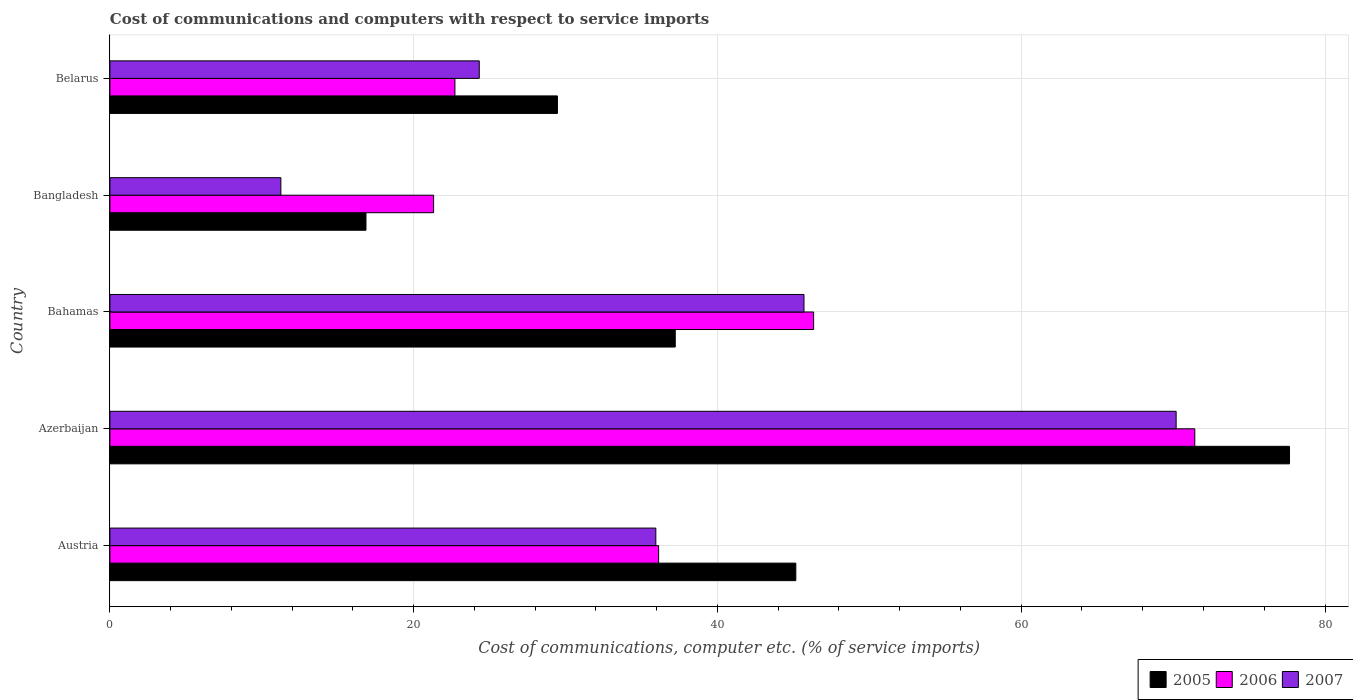How many different coloured bars are there?
Your answer should be very brief. 3. Are the number of bars on each tick of the Y-axis equal?
Your answer should be compact. Yes. How many bars are there on the 3rd tick from the top?
Provide a short and direct response. 3. What is the label of the 2nd group of bars from the top?
Your answer should be compact. Bangladesh. In how many cases, is the number of bars for a given country not equal to the number of legend labels?
Make the answer very short. 0. What is the cost of communications and computers in 2007 in Austria?
Provide a succinct answer. 35.94. Across all countries, what is the maximum cost of communications and computers in 2007?
Provide a succinct answer. 70.2. Across all countries, what is the minimum cost of communications and computers in 2006?
Offer a very short reply. 21.31. In which country was the cost of communications and computers in 2007 maximum?
Offer a very short reply. Azerbaijan. In which country was the cost of communications and computers in 2006 minimum?
Your answer should be very brief. Bangladesh. What is the total cost of communications and computers in 2007 in the graph?
Make the answer very short. 187.42. What is the difference between the cost of communications and computers in 2006 in Bahamas and that in Bangladesh?
Make the answer very short. 25.02. What is the difference between the cost of communications and computers in 2007 in Azerbaijan and the cost of communications and computers in 2005 in Austria?
Ensure brevity in your answer.  25.04. What is the average cost of communications and computers in 2005 per country?
Your answer should be compact. 41.27. What is the difference between the cost of communications and computers in 2006 and cost of communications and computers in 2005 in Belarus?
Provide a succinct answer. -6.75. What is the ratio of the cost of communications and computers in 2005 in Bangladesh to that in Belarus?
Provide a short and direct response. 0.57. Is the cost of communications and computers in 2005 in Azerbaijan less than that in Bahamas?
Ensure brevity in your answer.  No. What is the difference between the highest and the second highest cost of communications and computers in 2005?
Keep it short and to the point. 32.5. What is the difference between the highest and the lowest cost of communications and computers in 2005?
Offer a very short reply. 60.8. Is the sum of the cost of communications and computers in 2007 in Austria and Belarus greater than the maximum cost of communications and computers in 2005 across all countries?
Ensure brevity in your answer.  No. What does the 2nd bar from the top in Belarus represents?
Provide a succinct answer. 2006. How many countries are there in the graph?
Offer a terse response. 5. What is the difference between two consecutive major ticks on the X-axis?
Make the answer very short. 20. Does the graph contain any zero values?
Your answer should be compact. No. Where does the legend appear in the graph?
Your response must be concise. Bottom right. How many legend labels are there?
Your response must be concise. 3. What is the title of the graph?
Offer a terse response. Cost of communications and computers with respect to service imports. What is the label or title of the X-axis?
Provide a succinct answer. Cost of communications, computer etc. (% of service imports). What is the label or title of the Y-axis?
Make the answer very short. Country. What is the Cost of communications, computer etc. (% of service imports) in 2005 in Austria?
Your answer should be very brief. 45.16. What is the Cost of communications, computer etc. (% of service imports) in 2006 in Austria?
Provide a succinct answer. 36.13. What is the Cost of communications, computer etc. (% of service imports) in 2007 in Austria?
Provide a succinct answer. 35.94. What is the Cost of communications, computer etc. (% of service imports) of 2005 in Azerbaijan?
Provide a succinct answer. 77.66. What is the Cost of communications, computer etc. (% of service imports) in 2006 in Azerbaijan?
Make the answer very short. 71.43. What is the Cost of communications, computer etc. (% of service imports) in 2007 in Azerbaijan?
Your answer should be very brief. 70.2. What is the Cost of communications, computer etc. (% of service imports) of 2005 in Bahamas?
Your response must be concise. 37.22. What is the Cost of communications, computer etc. (% of service imports) in 2006 in Bahamas?
Your response must be concise. 46.33. What is the Cost of communications, computer etc. (% of service imports) of 2007 in Bahamas?
Provide a short and direct response. 45.7. What is the Cost of communications, computer etc. (% of service imports) of 2005 in Bangladesh?
Provide a short and direct response. 16.86. What is the Cost of communications, computer etc. (% of service imports) of 2006 in Bangladesh?
Ensure brevity in your answer.  21.31. What is the Cost of communications, computer etc. (% of service imports) of 2007 in Bangladesh?
Your answer should be compact. 11.26. What is the Cost of communications, computer etc. (% of service imports) in 2005 in Belarus?
Your answer should be very brief. 29.47. What is the Cost of communications, computer etc. (% of service imports) of 2006 in Belarus?
Make the answer very short. 22.72. What is the Cost of communications, computer etc. (% of service imports) in 2007 in Belarus?
Your answer should be very brief. 24.32. Across all countries, what is the maximum Cost of communications, computer etc. (% of service imports) of 2005?
Keep it short and to the point. 77.66. Across all countries, what is the maximum Cost of communications, computer etc. (% of service imports) of 2006?
Give a very brief answer. 71.43. Across all countries, what is the maximum Cost of communications, computer etc. (% of service imports) of 2007?
Make the answer very short. 70.2. Across all countries, what is the minimum Cost of communications, computer etc. (% of service imports) in 2005?
Provide a succinct answer. 16.86. Across all countries, what is the minimum Cost of communications, computer etc. (% of service imports) of 2006?
Provide a succinct answer. 21.31. Across all countries, what is the minimum Cost of communications, computer etc. (% of service imports) of 2007?
Keep it short and to the point. 11.26. What is the total Cost of communications, computer etc. (% of service imports) of 2005 in the graph?
Keep it short and to the point. 206.37. What is the total Cost of communications, computer etc. (% of service imports) of 2006 in the graph?
Ensure brevity in your answer.  197.92. What is the total Cost of communications, computer etc. (% of service imports) in 2007 in the graph?
Your response must be concise. 187.42. What is the difference between the Cost of communications, computer etc. (% of service imports) in 2005 in Austria and that in Azerbaijan?
Offer a terse response. -32.5. What is the difference between the Cost of communications, computer etc. (% of service imports) in 2006 in Austria and that in Azerbaijan?
Make the answer very short. -35.3. What is the difference between the Cost of communications, computer etc. (% of service imports) of 2007 in Austria and that in Azerbaijan?
Offer a very short reply. -34.26. What is the difference between the Cost of communications, computer etc. (% of service imports) in 2005 in Austria and that in Bahamas?
Ensure brevity in your answer.  7.94. What is the difference between the Cost of communications, computer etc. (% of service imports) in 2006 in Austria and that in Bahamas?
Provide a short and direct response. -10.2. What is the difference between the Cost of communications, computer etc. (% of service imports) in 2007 in Austria and that in Bahamas?
Make the answer very short. -9.75. What is the difference between the Cost of communications, computer etc. (% of service imports) of 2005 in Austria and that in Bangladesh?
Offer a very short reply. 28.3. What is the difference between the Cost of communications, computer etc. (% of service imports) of 2006 in Austria and that in Bangladesh?
Offer a terse response. 14.81. What is the difference between the Cost of communications, computer etc. (% of service imports) of 2007 in Austria and that in Bangladesh?
Your answer should be compact. 24.69. What is the difference between the Cost of communications, computer etc. (% of service imports) in 2005 in Austria and that in Belarus?
Make the answer very short. 15.7. What is the difference between the Cost of communications, computer etc. (% of service imports) of 2006 in Austria and that in Belarus?
Keep it short and to the point. 13.41. What is the difference between the Cost of communications, computer etc. (% of service imports) of 2007 in Austria and that in Belarus?
Your answer should be very brief. 11.62. What is the difference between the Cost of communications, computer etc. (% of service imports) of 2005 in Azerbaijan and that in Bahamas?
Provide a succinct answer. 40.44. What is the difference between the Cost of communications, computer etc. (% of service imports) of 2006 in Azerbaijan and that in Bahamas?
Your response must be concise. 25.1. What is the difference between the Cost of communications, computer etc. (% of service imports) of 2007 in Azerbaijan and that in Bahamas?
Give a very brief answer. 24.5. What is the difference between the Cost of communications, computer etc. (% of service imports) of 2005 in Azerbaijan and that in Bangladesh?
Provide a short and direct response. 60.8. What is the difference between the Cost of communications, computer etc. (% of service imports) of 2006 in Azerbaijan and that in Bangladesh?
Your answer should be very brief. 50.12. What is the difference between the Cost of communications, computer etc. (% of service imports) in 2007 in Azerbaijan and that in Bangladesh?
Provide a succinct answer. 58.94. What is the difference between the Cost of communications, computer etc. (% of service imports) in 2005 in Azerbaijan and that in Belarus?
Your response must be concise. 48.2. What is the difference between the Cost of communications, computer etc. (% of service imports) in 2006 in Azerbaijan and that in Belarus?
Make the answer very short. 48.71. What is the difference between the Cost of communications, computer etc. (% of service imports) in 2007 in Azerbaijan and that in Belarus?
Make the answer very short. 45.88. What is the difference between the Cost of communications, computer etc. (% of service imports) in 2005 in Bahamas and that in Bangladesh?
Your response must be concise. 20.36. What is the difference between the Cost of communications, computer etc. (% of service imports) in 2006 in Bahamas and that in Bangladesh?
Your answer should be very brief. 25.02. What is the difference between the Cost of communications, computer etc. (% of service imports) of 2007 in Bahamas and that in Bangladesh?
Your answer should be compact. 34.44. What is the difference between the Cost of communications, computer etc. (% of service imports) of 2005 in Bahamas and that in Belarus?
Provide a short and direct response. 7.76. What is the difference between the Cost of communications, computer etc. (% of service imports) of 2006 in Bahamas and that in Belarus?
Give a very brief answer. 23.62. What is the difference between the Cost of communications, computer etc. (% of service imports) in 2007 in Bahamas and that in Belarus?
Your response must be concise. 21.38. What is the difference between the Cost of communications, computer etc. (% of service imports) in 2005 in Bangladesh and that in Belarus?
Provide a succinct answer. -12.61. What is the difference between the Cost of communications, computer etc. (% of service imports) in 2006 in Bangladesh and that in Belarus?
Give a very brief answer. -1.4. What is the difference between the Cost of communications, computer etc. (% of service imports) in 2007 in Bangladesh and that in Belarus?
Your answer should be compact. -13.06. What is the difference between the Cost of communications, computer etc. (% of service imports) in 2005 in Austria and the Cost of communications, computer etc. (% of service imports) in 2006 in Azerbaijan?
Offer a terse response. -26.27. What is the difference between the Cost of communications, computer etc. (% of service imports) in 2005 in Austria and the Cost of communications, computer etc. (% of service imports) in 2007 in Azerbaijan?
Your answer should be compact. -25.04. What is the difference between the Cost of communications, computer etc. (% of service imports) in 2006 in Austria and the Cost of communications, computer etc. (% of service imports) in 2007 in Azerbaijan?
Give a very brief answer. -34.07. What is the difference between the Cost of communications, computer etc. (% of service imports) in 2005 in Austria and the Cost of communications, computer etc. (% of service imports) in 2006 in Bahamas?
Provide a short and direct response. -1.17. What is the difference between the Cost of communications, computer etc. (% of service imports) of 2005 in Austria and the Cost of communications, computer etc. (% of service imports) of 2007 in Bahamas?
Offer a very short reply. -0.54. What is the difference between the Cost of communications, computer etc. (% of service imports) in 2006 in Austria and the Cost of communications, computer etc. (% of service imports) in 2007 in Bahamas?
Give a very brief answer. -9.57. What is the difference between the Cost of communications, computer etc. (% of service imports) of 2005 in Austria and the Cost of communications, computer etc. (% of service imports) of 2006 in Bangladesh?
Keep it short and to the point. 23.85. What is the difference between the Cost of communications, computer etc. (% of service imports) of 2005 in Austria and the Cost of communications, computer etc. (% of service imports) of 2007 in Bangladesh?
Offer a very short reply. 33.9. What is the difference between the Cost of communications, computer etc. (% of service imports) in 2006 in Austria and the Cost of communications, computer etc. (% of service imports) in 2007 in Bangladesh?
Your answer should be compact. 24.87. What is the difference between the Cost of communications, computer etc. (% of service imports) of 2005 in Austria and the Cost of communications, computer etc. (% of service imports) of 2006 in Belarus?
Ensure brevity in your answer.  22.44. What is the difference between the Cost of communications, computer etc. (% of service imports) in 2005 in Austria and the Cost of communications, computer etc. (% of service imports) in 2007 in Belarus?
Keep it short and to the point. 20.84. What is the difference between the Cost of communications, computer etc. (% of service imports) of 2006 in Austria and the Cost of communications, computer etc. (% of service imports) of 2007 in Belarus?
Your answer should be compact. 11.81. What is the difference between the Cost of communications, computer etc. (% of service imports) of 2005 in Azerbaijan and the Cost of communications, computer etc. (% of service imports) of 2006 in Bahamas?
Provide a succinct answer. 31.33. What is the difference between the Cost of communications, computer etc. (% of service imports) of 2005 in Azerbaijan and the Cost of communications, computer etc. (% of service imports) of 2007 in Bahamas?
Your response must be concise. 31.97. What is the difference between the Cost of communications, computer etc. (% of service imports) in 2006 in Azerbaijan and the Cost of communications, computer etc. (% of service imports) in 2007 in Bahamas?
Provide a short and direct response. 25.73. What is the difference between the Cost of communications, computer etc. (% of service imports) in 2005 in Azerbaijan and the Cost of communications, computer etc. (% of service imports) in 2006 in Bangladesh?
Provide a succinct answer. 56.35. What is the difference between the Cost of communications, computer etc. (% of service imports) of 2005 in Azerbaijan and the Cost of communications, computer etc. (% of service imports) of 2007 in Bangladesh?
Provide a short and direct response. 66.41. What is the difference between the Cost of communications, computer etc. (% of service imports) of 2006 in Azerbaijan and the Cost of communications, computer etc. (% of service imports) of 2007 in Bangladesh?
Your response must be concise. 60.17. What is the difference between the Cost of communications, computer etc. (% of service imports) of 2005 in Azerbaijan and the Cost of communications, computer etc. (% of service imports) of 2006 in Belarus?
Your answer should be compact. 54.95. What is the difference between the Cost of communications, computer etc. (% of service imports) of 2005 in Azerbaijan and the Cost of communications, computer etc. (% of service imports) of 2007 in Belarus?
Offer a very short reply. 53.34. What is the difference between the Cost of communications, computer etc. (% of service imports) in 2006 in Azerbaijan and the Cost of communications, computer etc. (% of service imports) in 2007 in Belarus?
Your answer should be compact. 47.11. What is the difference between the Cost of communications, computer etc. (% of service imports) in 2005 in Bahamas and the Cost of communications, computer etc. (% of service imports) in 2006 in Bangladesh?
Offer a terse response. 15.91. What is the difference between the Cost of communications, computer etc. (% of service imports) in 2005 in Bahamas and the Cost of communications, computer etc. (% of service imports) in 2007 in Bangladesh?
Keep it short and to the point. 25.97. What is the difference between the Cost of communications, computer etc. (% of service imports) of 2006 in Bahamas and the Cost of communications, computer etc. (% of service imports) of 2007 in Bangladesh?
Keep it short and to the point. 35.08. What is the difference between the Cost of communications, computer etc. (% of service imports) of 2005 in Bahamas and the Cost of communications, computer etc. (% of service imports) of 2006 in Belarus?
Provide a succinct answer. 14.51. What is the difference between the Cost of communications, computer etc. (% of service imports) of 2005 in Bahamas and the Cost of communications, computer etc. (% of service imports) of 2007 in Belarus?
Provide a succinct answer. 12.9. What is the difference between the Cost of communications, computer etc. (% of service imports) in 2006 in Bahamas and the Cost of communications, computer etc. (% of service imports) in 2007 in Belarus?
Keep it short and to the point. 22.01. What is the difference between the Cost of communications, computer etc. (% of service imports) of 2005 in Bangladesh and the Cost of communications, computer etc. (% of service imports) of 2006 in Belarus?
Make the answer very short. -5.86. What is the difference between the Cost of communications, computer etc. (% of service imports) of 2005 in Bangladesh and the Cost of communications, computer etc. (% of service imports) of 2007 in Belarus?
Provide a succinct answer. -7.46. What is the difference between the Cost of communications, computer etc. (% of service imports) in 2006 in Bangladesh and the Cost of communications, computer etc. (% of service imports) in 2007 in Belarus?
Make the answer very short. -3.01. What is the average Cost of communications, computer etc. (% of service imports) in 2005 per country?
Ensure brevity in your answer.  41.27. What is the average Cost of communications, computer etc. (% of service imports) of 2006 per country?
Offer a very short reply. 39.58. What is the average Cost of communications, computer etc. (% of service imports) in 2007 per country?
Make the answer very short. 37.48. What is the difference between the Cost of communications, computer etc. (% of service imports) in 2005 and Cost of communications, computer etc. (% of service imports) in 2006 in Austria?
Your response must be concise. 9.03. What is the difference between the Cost of communications, computer etc. (% of service imports) of 2005 and Cost of communications, computer etc. (% of service imports) of 2007 in Austria?
Keep it short and to the point. 9.22. What is the difference between the Cost of communications, computer etc. (% of service imports) of 2006 and Cost of communications, computer etc. (% of service imports) of 2007 in Austria?
Provide a succinct answer. 0.18. What is the difference between the Cost of communications, computer etc. (% of service imports) of 2005 and Cost of communications, computer etc. (% of service imports) of 2006 in Azerbaijan?
Your answer should be compact. 6.24. What is the difference between the Cost of communications, computer etc. (% of service imports) in 2005 and Cost of communications, computer etc. (% of service imports) in 2007 in Azerbaijan?
Offer a very short reply. 7.46. What is the difference between the Cost of communications, computer etc. (% of service imports) of 2006 and Cost of communications, computer etc. (% of service imports) of 2007 in Azerbaijan?
Your answer should be very brief. 1.23. What is the difference between the Cost of communications, computer etc. (% of service imports) in 2005 and Cost of communications, computer etc. (% of service imports) in 2006 in Bahamas?
Provide a short and direct response. -9.11. What is the difference between the Cost of communications, computer etc. (% of service imports) in 2005 and Cost of communications, computer etc. (% of service imports) in 2007 in Bahamas?
Keep it short and to the point. -8.48. What is the difference between the Cost of communications, computer etc. (% of service imports) of 2006 and Cost of communications, computer etc. (% of service imports) of 2007 in Bahamas?
Provide a short and direct response. 0.63. What is the difference between the Cost of communications, computer etc. (% of service imports) of 2005 and Cost of communications, computer etc. (% of service imports) of 2006 in Bangladesh?
Offer a very short reply. -4.45. What is the difference between the Cost of communications, computer etc. (% of service imports) of 2005 and Cost of communications, computer etc. (% of service imports) of 2007 in Bangladesh?
Offer a terse response. 5.6. What is the difference between the Cost of communications, computer etc. (% of service imports) of 2006 and Cost of communications, computer etc. (% of service imports) of 2007 in Bangladesh?
Your answer should be very brief. 10.06. What is the difference between the Cost of communications, computer etc. (% of service imports) in 2005 and Cost of communications, computer etc. (% of service imports) in 2006 in Belarus?
Your answer should be very brief. 6.75. What is the difference between the Cost of communications, computer etc. (% of service imports) of 2005 and Cost of communications, computer etc. (% of service imports) of 2007 in Belarus?
Offer a very short reply. 5.15. What is the difference between the Cost of communications, computer etc. (% of service imports) in 2006 and Cost of communications, computer etc. (% of service imports) in 2007 in Belarus?
Ensure brevity in your answer.  -1.6. What is the ratio of the Cost of communications, computer etc. (% of service imports) of 2005 in Austria to that in Azerbaijan?
Make the answer very short. 0.58. What is the ratio of the Cost of communications, computer etc. (% of service imports) in 2006 in Austria to that in Azerbaijan?
Provide a short and direct response. 0.51. What is the ratio of the Cost of communications, computer etc. (% of service imports) of 2007 in Austria to that in Azerbaijan?
Your answer should be very brief. 0.51. What is the ratio of the Cost of communications, computer etc. (% of service imports) in 2005 in Austria to that in Bahamas?
Make the answer very short. 1.21. What is the ratio of the Cost of communications, computer etc. (% of service imports) of 2006 in Austria to that in Bahamas?
Your answer should be very brief. 0.78. What is the ratio of the Cost of communications, computer etc. (% of service imports) in 2007 in Austria to that in Bahamas?
Your answer should be very brief. 0.79. What is the ratio of the Cost of communications, computer etc. (% of service imports) in 2005 in Austria to that in Bangladesh?
Offer a terse response. 2.68. What is the ratio of the Cost of communications, computer etc. (% of service imports) of 2006 in Austria to that in Bangladesh?
Provide a short and direct response. 1.7. What is the ratio of the Cost of communications, computer etc. (% of service imports) in 2007 in Austria to that in Bangladesh?
Provide a short and direct response. 3.19. What is the ratio of the Cost of communications, computer etc. (% of service imports) of 2005 in Austria to that in Belarus?
Your answer should be compact. 1.53. What is the ratio of the Cost of communications, computer etc. (% of service imports) in 2006 in Austria to that in Belarus?
Provide a short and direct response. 1.59. What is the ratio of the Cost of communications, computer etc. (% of service imports) in 2007 in Austria to that in Belarus?
Your answer should be compact. 1.48. What is the ratio of the Cost of communications, computer etc. (% of service imports) of 2005 in Azerbaijan to that in Bahamas?
Your response must be concise. 2.09. What is the ratio of the Cost of communications, computer etc. (% of service imports) in 2006 in Azerbaijan to that in Bahamas?
Give a very brief answer. 1.54. What is the ratio of the Cost of communications, computer etc. (% of service imports) in 2007 in Azerbaijan to that in Bahamas?
Your answer should be compact. 1.54. What is the ratio of the Cost of communications, computer etc. (% of service imports) in 2005 in Azerbaijan to that in Bangladesh?
Keep it short and to the point. 4.61. What is the ratio of the Cost of communications, computer etc. (% of service imports) of 2006 in Azerbaijan to that in Bangladesh?
Give a very brief answer. 3.35. What is the ratio of the Cost of communications, computer etc. (% of service imports) in 2007 in Azerbaijan to that in Bangladesh?
Provide a short and direct response. 6.24. What is the ratio of the Cost of communications, computer etc. (% of service imports) in 2005 in Azerbaijan to that in Belarus?
Make the answer very short. 2.64. What is the ratio of the Cost of communications, computer etc. (% of service imports) in 2006 in Azerbaijan to that in Belarus?
Your response must be concise. 3.14. What is the ratio of the Cost of communications, computer etc. (% of service imports) in 2007 in Azerbaijan to that in Belarus?
Provide a succinct answer. 2.89. What is the ratio of the Cost of communications, computer etc. (% of service imports) in 2005 in Bahamas to that in Bangladesh?
Your answer should be very brief. 2.21. What is the ratio of the Cost of communications, computer etc. (% of service imports) of 2006 in Bahamas to that in Bangladesh?
Keep it short and to the point. 2.17. What is the ratio of the Cost of communications, computer etc. (% of service imports) in 2007 in Bahamas to that in Bangladesh?
Your response must be concise. 4.06. What is the ratio of the Cost of communications, computer etc. (% of service imports) in 2005 in Bahamas to that in Belarus?
Ensure brevity in your answer.  1.26. What is the ratio of the Cost of communications, computer etc. (% of service imports) of 2006 in Bahamas to that in Belarus?
Give a very brief answer. 2.04. What is the ratio of the Cost of communications, computer etc. (% of service imports) of 2007 in Bahamas to that in Belarus?
Offer a very short reply. 1.88. What is the ratio of the Cost of communications, computer etc. (% of service imports) of 2005 in Bangladesh to that in Belarus?
Your answer should be compact. 0.57. What is the ratio of the Cost of communications, computer etc. (% of service imports) in 2006 in Bangladesh to that in Belarus?
Keep it short and to the point. 0.94. What is the ratio of the Cost of communications, computer etc. (% of service imports) of 2007 in Bangladesh to that in Belarus?
Provide a short and direct response. 0.46. What is the difference between the highest and the second highest Cost of communications, computer etc. (% of service imports) in 2005?
Keep it short and to the point. 32.5. What is the difference between the highest and the second highest Cost of communications, computer etc. (% of service imports) in 2006?
Ensure brevity in your answer.  25.1. What is the difference between the highest and the second highest Cost of communications, computer etc. (% of service imports) in 2007?
Make the answer very short. 24.5. What is the difference between the highest and the lowest Cost of communications, computer etc. (% of service imports) in 2005?
Your answer should be compact. 60.8. What is the difference between the highest and the lowest Cost of communications, computer etc. (% of service imports) in 2006?
Offer a terse response. 50.12. What is the difference between the highest and the lowest Cost of communications, computer etc. (% of service imports) in 2007?
Your response must be concise. 58.94. 